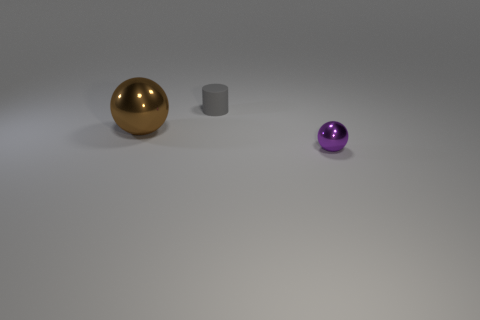Add 2 small matte cylinders. How many objects exist? 5 Subtract all balls. How many objects are left? 1 Add 1 large blue metallic spheres. How many large blue metallic spheres exist? 1 Subtract 0 purple cubes. How many objects are left? 3 Subtract all purple spheres. Subtract all big brown shiny spheres. How many objects are left? 1 Add 1 small balls. How many small balls are left? 2 